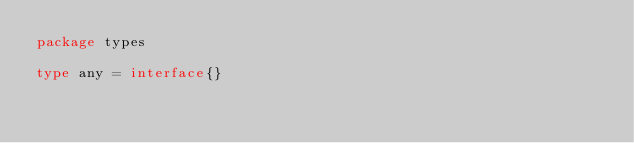<code> <loc_0><loc_0><loc_500><loc_500><_Go_>package types

type any = interface{}
</code> 